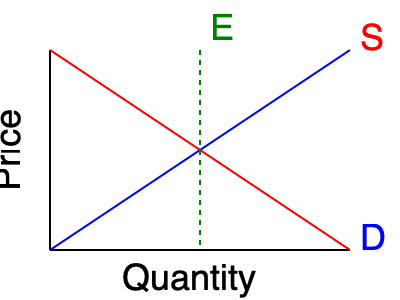In a niche market for handcrafted artisanal soaps, the supply and demand curves are represented in the graph above. If a new supplier enters the market, increasing the supply by 20%, how would this affect the equilibrium price and quantity? Assume a linear shift in the supply curve. To analyze the effect of a 20% increase in supply on the equilibrium price and quantity, let's follow these steps:

1. Identify the initial equilibrium point:
   The initial equilibrium is at point E, where the supply (S) and demand (D) curves intersect.

2. Understand the supply increase:
   A 20% increase in supply means the supply curve will shift to the right.

3. Visualize the new supply curve:
   Imagine a new supply curve parallel to the original one, shifted 20% to the right.

4. Determine the new equilibrium point:
   The new equilibrium will be where the new supply curve intersects the original demand curve.

5. Analyze the changes:
   a) Equilibrium quantity: Will increase as the new intersection point moves right along the demand curve.
   b) Equilibrium price: Will decrease as the new intersection point moves down along the demand curve.

6. Quantify the changes (approximate):
   Without specific numerical values, we can estimate that:
   - Quantity will increase by less than 20% (due to the downward-sloping demand curve)
   - Price will decrease (by a percentage dependent on the elasticities of supply and demand)

7. Market implications:
   - More handcrafted artisanal soaps will be sold in the market
   - Consumers will benefit from lower prices
   - Existing suppliers may face increased competition and potentially lower profit margins
Answer: Equilibrium price decreases, equilibrium quantity increases 